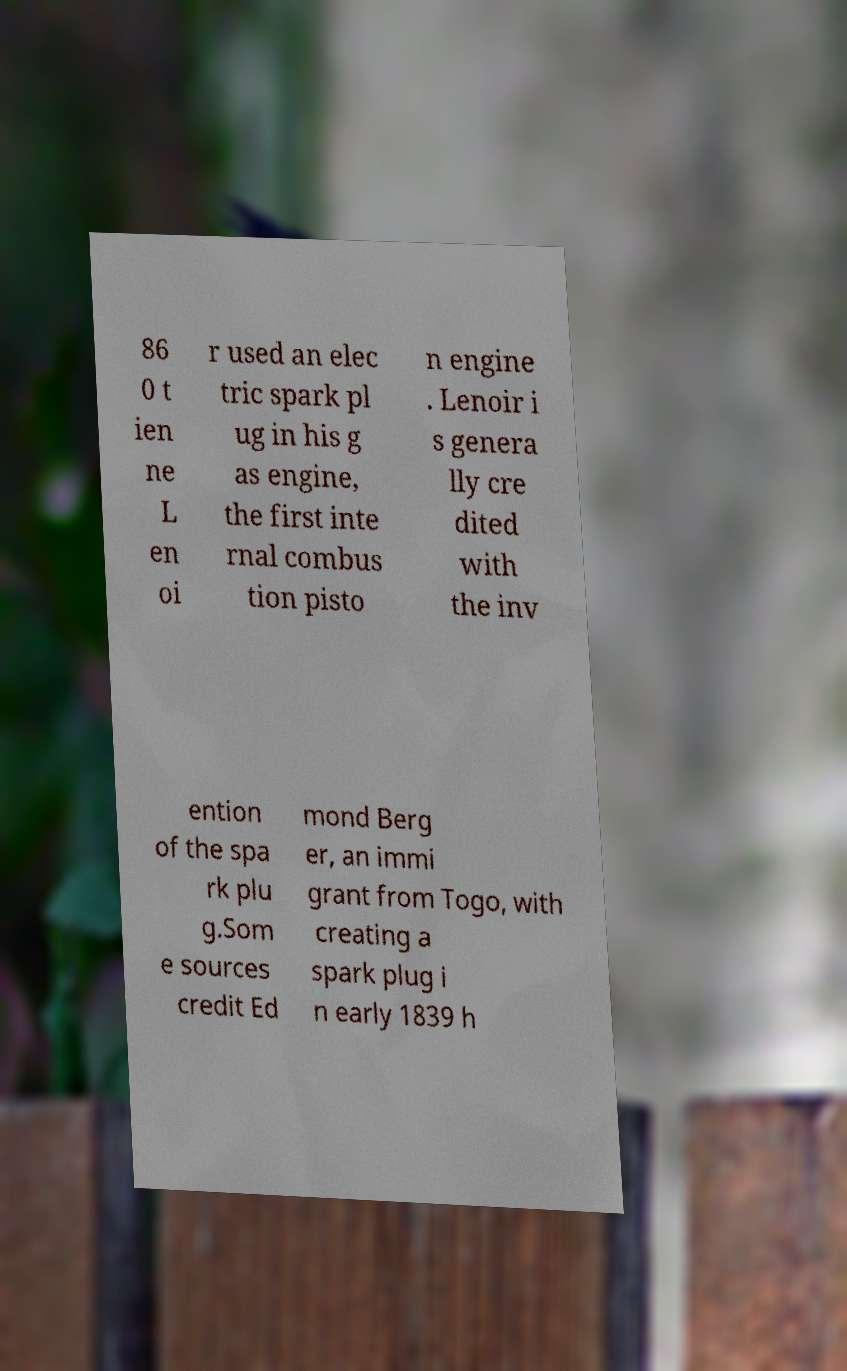Can you read and provide the text displayed in the image?This photo seems to have some interesting text. Can you extract and type it out for me? 86 0 t ien ne L en oi r used an elec tric spark pl ug in his g as engine, the first inte rnal combus tion pisto n engine . Lenoir i s genera lly cre dited with the inv ention of the spa rk plu g.Som e sources credit Ed mond Berg er, an immi grant from Togo, with creating a spark plug i n early 1839 h 